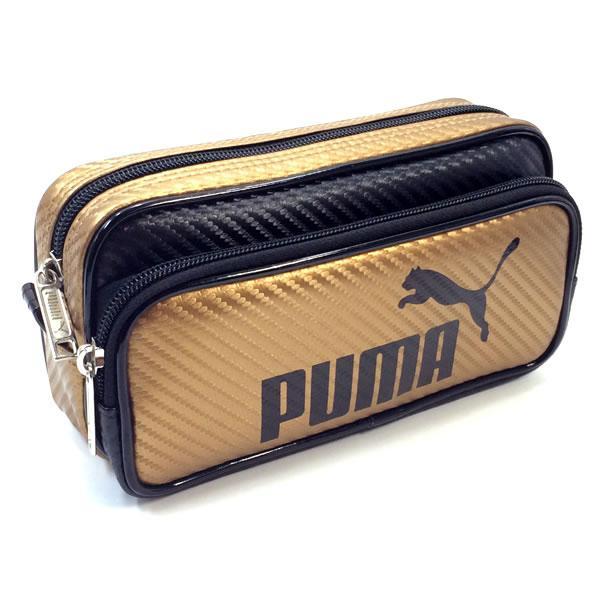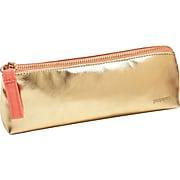The first image is the image on the left, the second image is the image on the right. Evaluate the accuracy of this statement regarding the images: "Exactly one bag has the company name and the company logo on it.". Is it true? Answer yes or no. Yes. The first image is the image on the left, the second image is the image on the right. Evaluate the accuracy of this statement regarding the images: "Each image contains one pencil case with a wildcat silhouette on it, and the right image features a case with a curving line that separates its colors.". Is it true? Answer yes or no. No. 